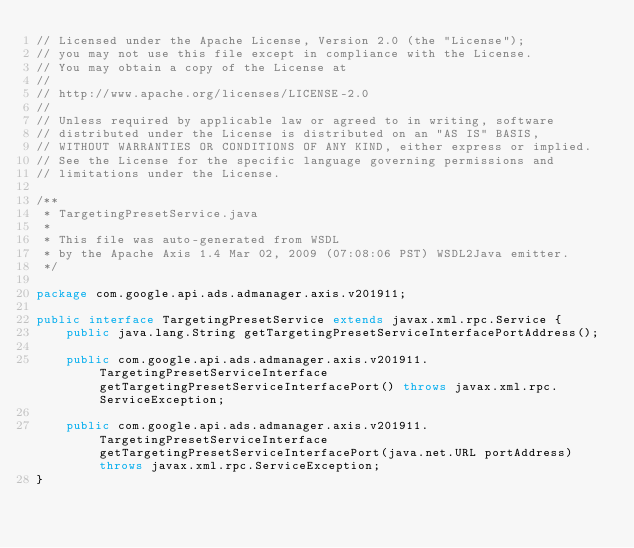<code> <loc_0><loc_0><loc_500><loc_500><_Java_>// Licensed under the Apache License, Version 2.0 (the "License");
// you may not use this file except in compliance with the License.
// You may obtain a copy of the License at
//
// http://www.apache.org/licenses/LICENSE-2.0
//
// Unless required by applicable law or agreed to in writing, software
// distributed under the License is distributed on an "AS IS" BASIS,
// WITHOUT WARRANTIES OR CONDITIONS OF ANY KIND, either express or implied.
// See the License for the specific language governing permissions and
// limitations under the License.

/**
 * TargetingPresetService.java
 *
 * This file was auto-generated from WSDL
 * by the Apache Axis 1.4 Mar 02, 2009 (07:08:06 PST) WSDL2Java emitter.
 */

package com.google.api.ads.admanager.axis.v201911;

public interface TargetingPresetService extends javax.xml.rpc.Service {
    public java.lang.String getTargetingPresetServiceInterfacePortAddress();

    public com.google.api.ads.admanager.axis.v201911.TargetingPresetServiceInterface getTargetingPresetServiceInterfacePort() throws javax.xml.rpc.ServiceException;

    public com.google.api.ads.admanager.axis.v201911.TargetingPresetServiceInterface getTargetingPresetServiceInterfacePort(java.net.URL portAddress) throws javax.xml.rpc.ServiceException;
}
</code> 